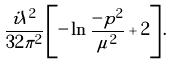Convert formula to latex. <formula><loc_0><loc_0><loc_500><loc_500>\frac { i \lambda ^ { 2 } } { 3 2 \pi ^ { 2 } } \left [ - \ln \frac { - p ^ { 2 } } { \mu ^ { 2 } } + 2 \right ] .</formula> 